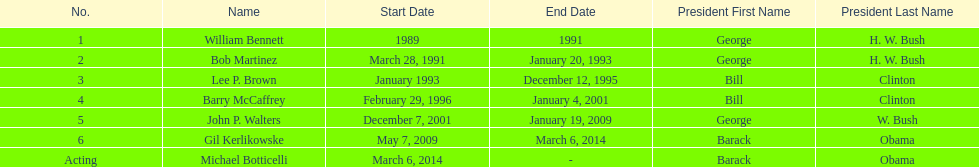How long did lee p. brown serve for? 2 years. 